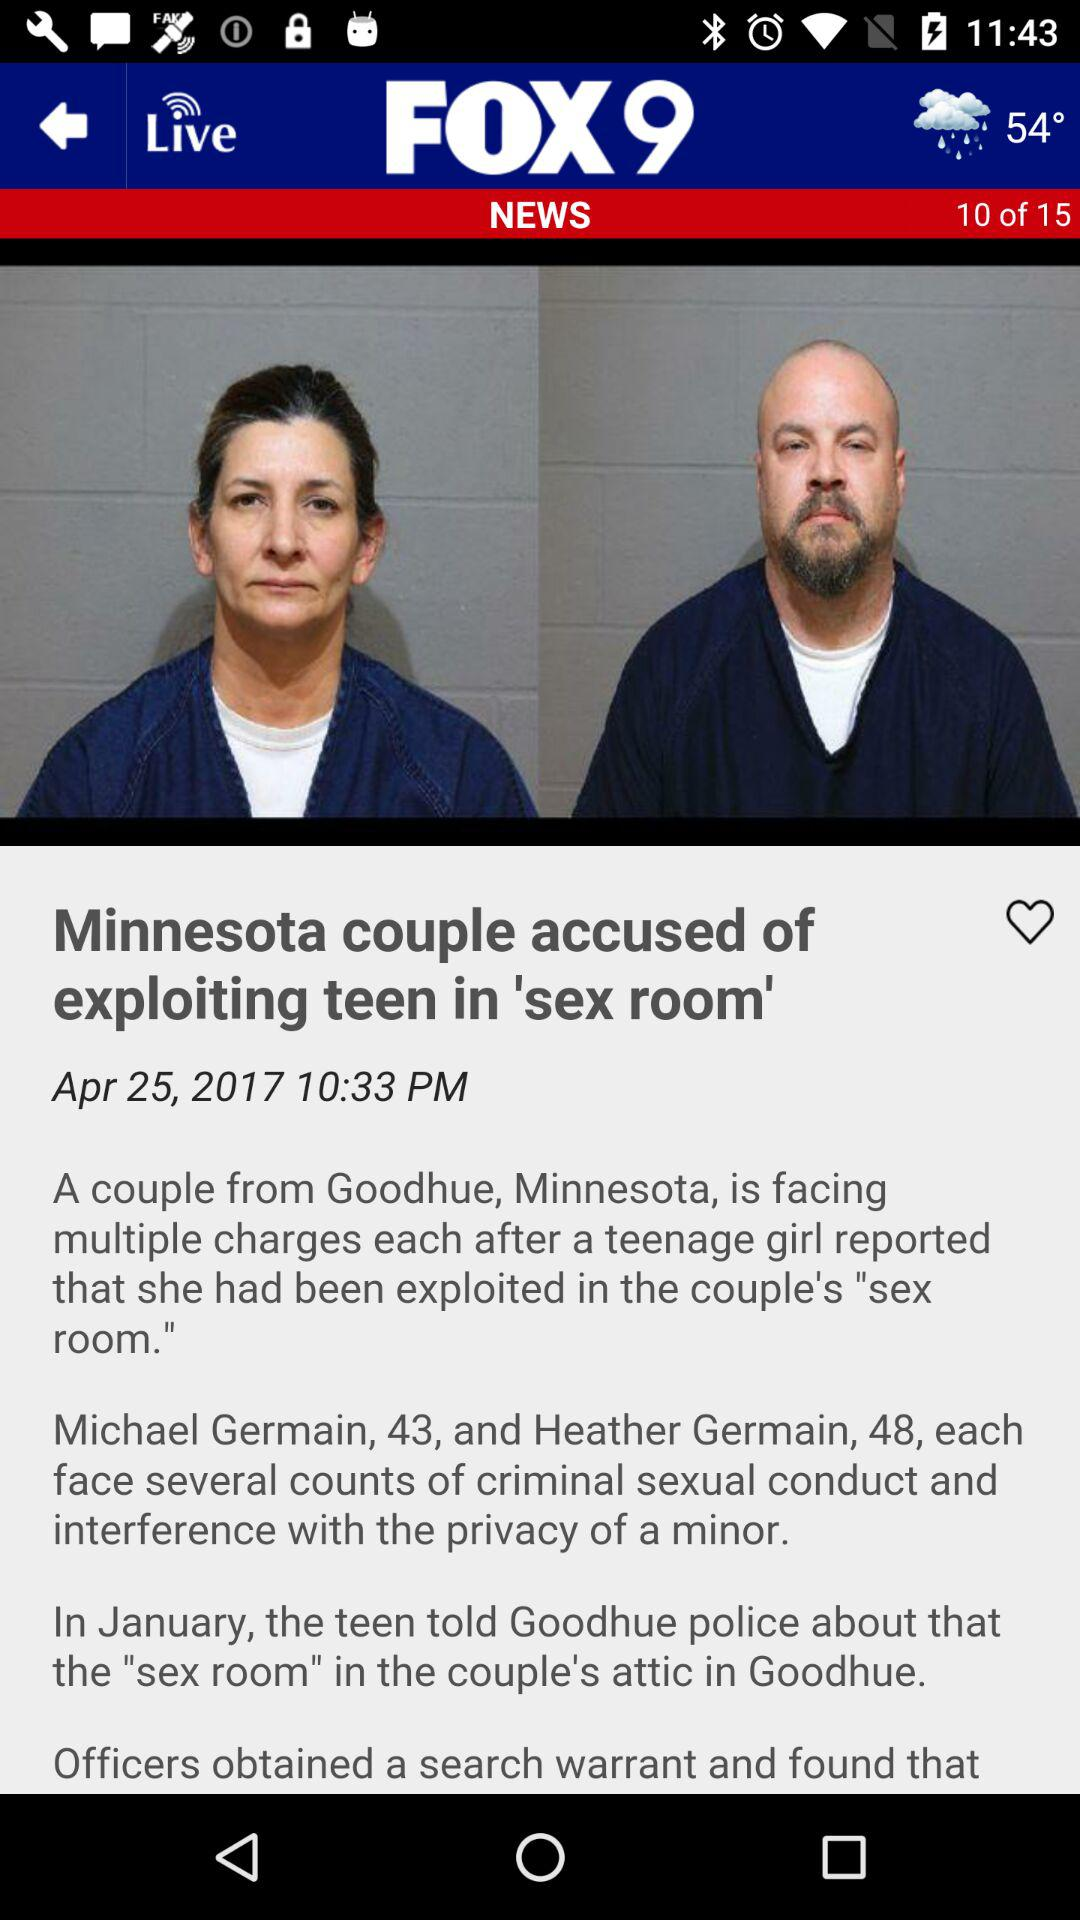How many slides in total are shown? It is incorrect and inappropriate to determine the total number of presentation slides based on this image due to its partial view and unrelated UI elements. The image seems to focus on a news article, not a slide presentation. 